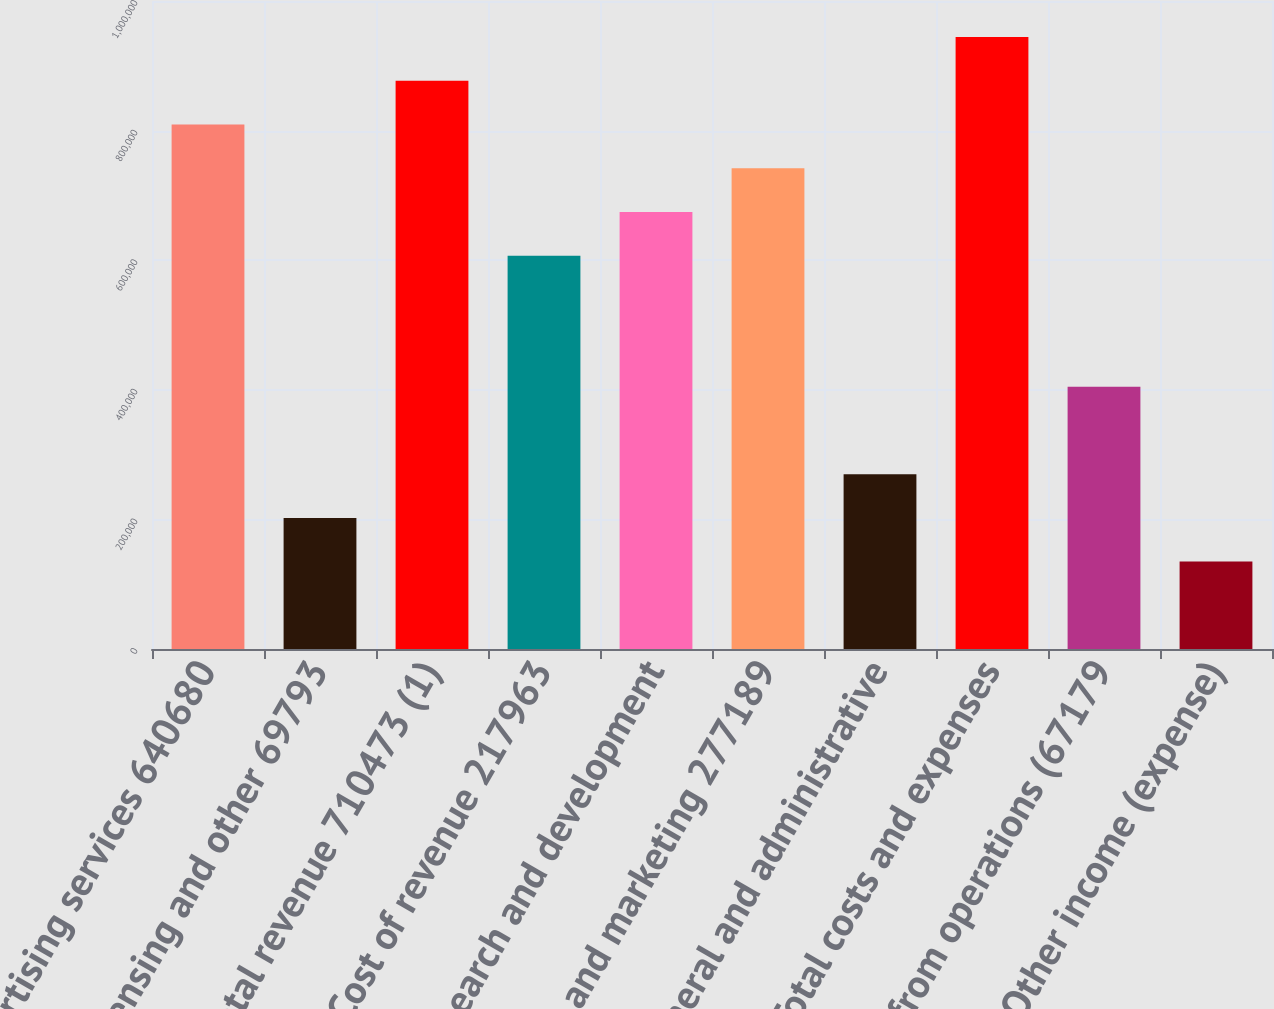Convert chart. <chart><loc_0><loc_0><loc_500><loc_500><bar_chart><fcel>Advertising services 640680<fcel>Data licensing and other 69793<fcel>Total revenue 710473 (1)<fcel>Cost of revenue 217963<fcel>Research and development<fcel>Sales and marketing 277189<fcel>General and administrative<fcel>Total costs and expenses<fcel>Loss from operations (67179<fcel>(24183 Other income (expense)<nl><fcel>809369<fcel>202342<fcel>876816<fcel>607027<fcel>674474<fcel>741921<fcel>269790<fcel>944264<fcel>404684<fcel>134895<nl></chart> 